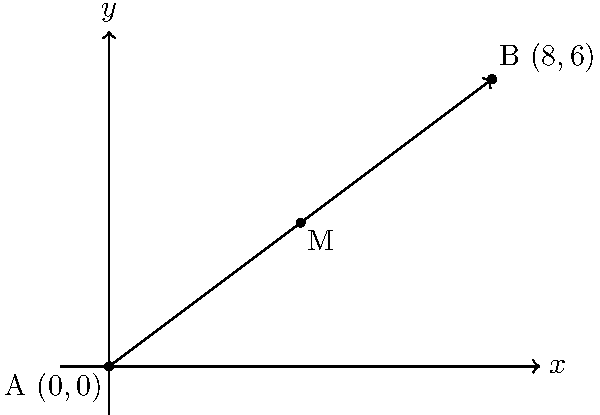During a bird-watching expedition, you observe a rare species flying from point A $(0,0)$ to point B $(8,6)$. As an architect with a keen eye for spatial relationships, you're interested in finding the midpoint of the bird's flight path. Calculate the coordinates of the midpoint M of line segment AB. To find the midpoint of a line segment, we can use the midpoint formula:

$$ M = (\frac{x_1 + x_2}{2}, \frac{y_1 + y_2}{2}) $$

Where $(x_1, y_1)$ are the coordinates of point A, and $(x_2, y_2)$ are the coordinates of point B.

Given:
Point A: $(0,0)$
Point B: $(8,6)$

Step 1: Calculate the x-coordinate of the midpoint:
$$ x_M = \frac{x_1 + x_2}{2} = \frac{0 + 8}{2} = \frac{8}{2} = 4 $$

Step 2: Calculate the y-coordinate of the midpoint:
$$ y_M = \frac{y_1 + y_2}{2} = \frac{0 + 6}{2} = \frac{6}{2} = 3 $$

Therefore, the coordinates of the midpoint M are $(4,3)$.
Answer: $(4,3)$ 